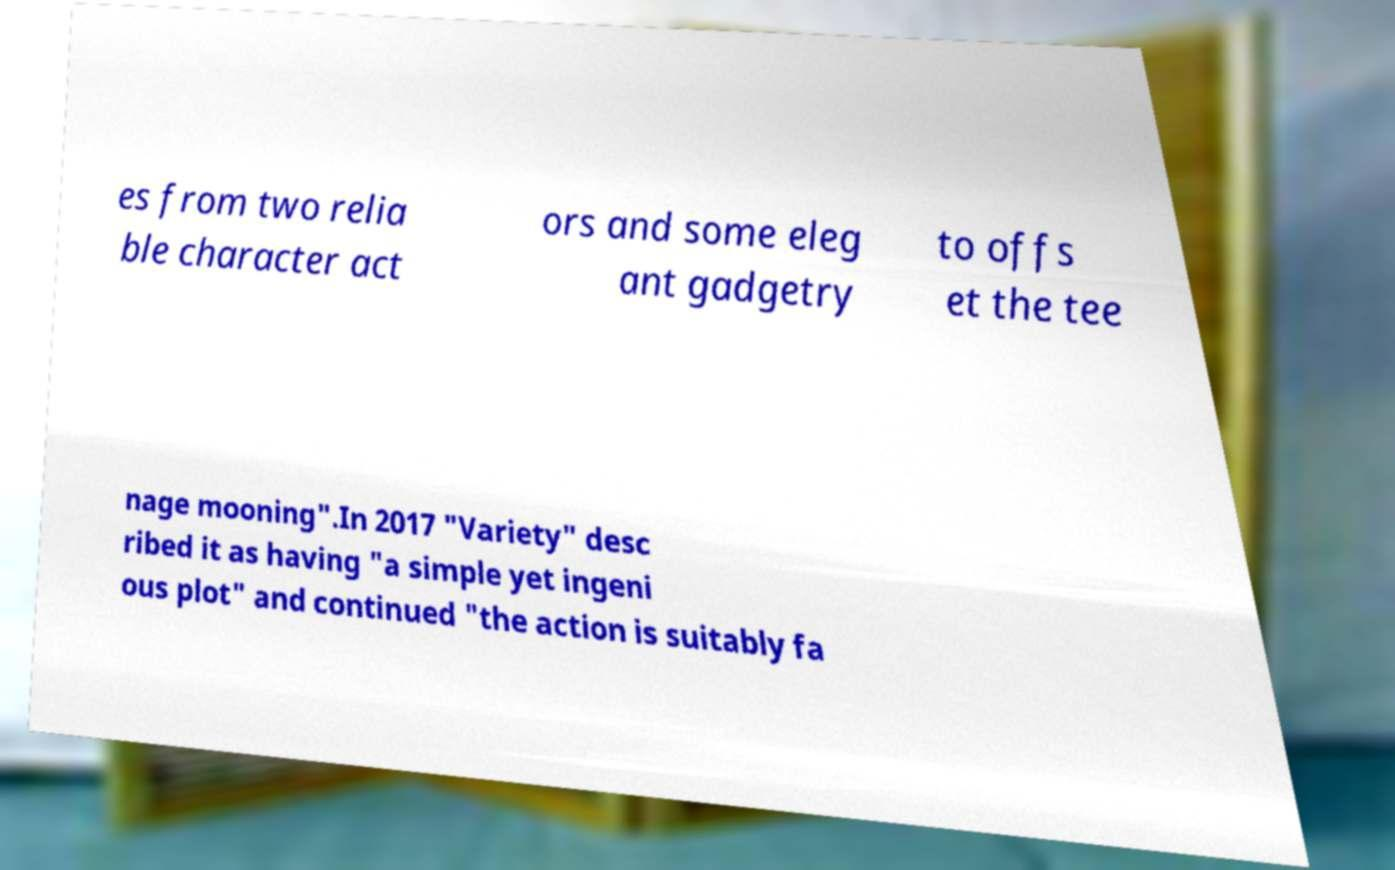For documentation purposes, I need the text within this image transcribed. Could you provide that? es from two relia ble character act ors and some eleg ant gadgetry to offs et the tee nage mooning".In 2017 "Variety" desc ribed it as having "a simple yet ingeni ous plot" and continued "the action is suitably fa 